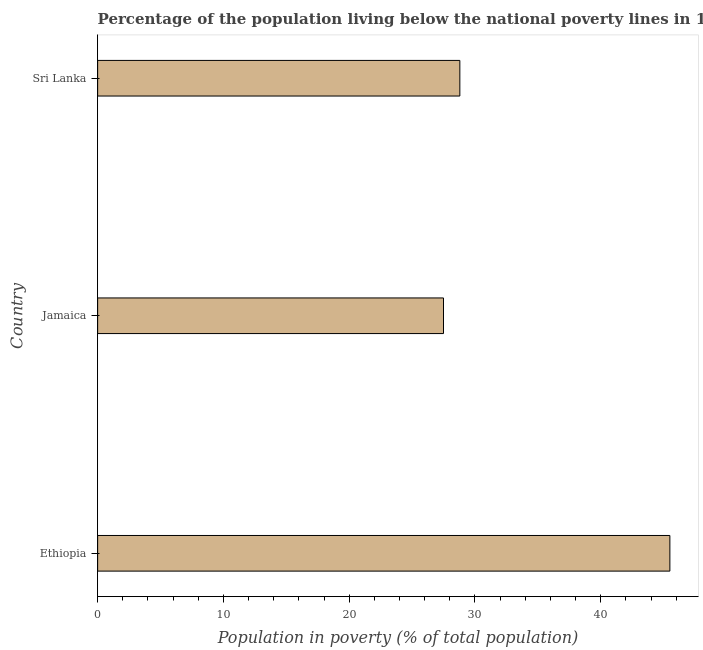Does the graph contain grids?
Your answer should be very brief. No. What is the title of the graph?
Ensure brevity in your answer.  Percentage of the population living below the national poverty lines in 1995. What is the label or title of the X-axis?
Ensure brevity in your answer.  Population in poverty (% of total population). What is the label or title of the Y-axis?
Provide a succinct answer. Country. Across all countries, what is the maximum percentage of population living below poverty line?
Offer a terse response. 45.5. Across all countries, what is the minimum percentage of population living below poverty line?
Make the answer very short. 27.5. In which country was the percentage of population living below poverty line maximum?
Your answer should be very brief. Ethiopia. In which country was the percentage of population living below poverty line minimum?
Your response must be concise. Jamaica. What is the sum of the percentage of population living below poverty line?
Your answer should be compact. 101.8. What is the average percentage of population living below poverty line per country?
Give a very brief answer. 33.93. What is the median percentage of population living below poverty line?
Your answer should be very brief. 28.8. In how many countries, is the percentage of population living below poverty line greater than 14 %?
Your response must be concise. 3. What is the ratio of the percentage of population living below poverty line in Ethiopia to that in Jamaica?
Your answer should be very brief. 1.66. Is the percentage of population living below poverty line in Ethiopia less than that in Sri Lanka?
Provide a succinct answer. No. Is the difference between the percentage of population living below poverty line in Ethiopia and Sri Lanka greater than the difference between any two countries?
Ensure brevity in your answer.  No. What is the difference between the highest and the second highest percentage of population living below poverty line?
Your answer should be compact. 16.7. Is the sum of the percentage of population living below poverty line in Ethiopia and Jamaica greater than the maximum percentage of population living below poverty line across all countries?
Offer a very short reply. Yes. How many countries are there in the graph?
Ensure brevity in your answer.  3. What is the difference between two consecutive major ticks on the X-axis?
Give a very brief answer. 10. What is the Population in poverty (% of total population) in Ethiopia?
Your response must be concise. 45.5. What is the Population in poverty (% of total population) of Sri Lanka?
Ensure brevity in your answer.  28.8. What is the difference between the Population in poverty (% of total population) in Jamaica and Sri Lanka?
Your answer should be compact. -1.3. What is the ratio of the Population in poverty (% of total population) in Ethiopia to that in Jamaica?
Give a very brief answer. 1.66. What is the ratio of the Population in poverty (% of total population) in Ethiopia to that in Sri Lanka?
Give a very brief answer. 1.58. What is the ratio of the Population in poverty (% of total population) in Jamaica to that in Sri Lanka?
Your answer should be very brief. 0.95. 